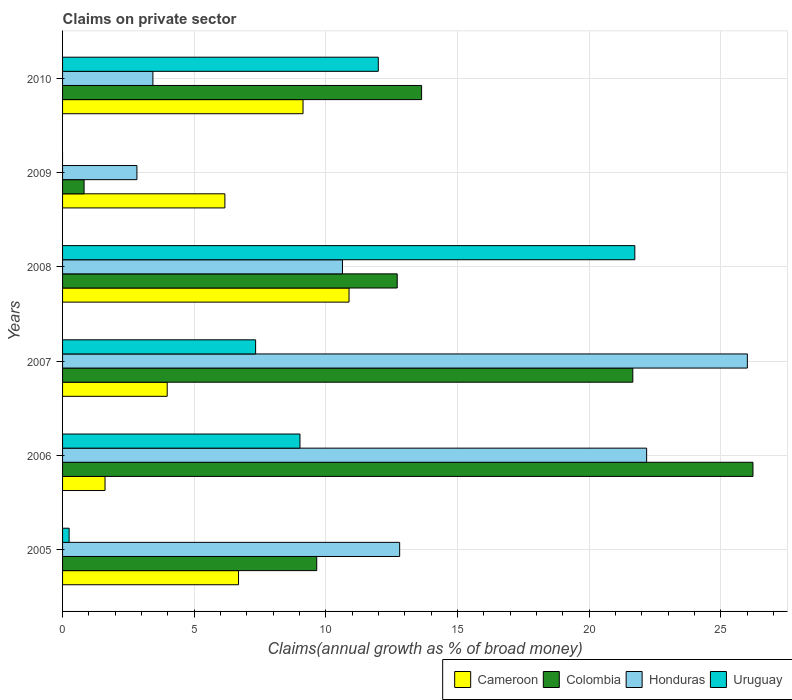How many different coloured bars are there?
Give a very brief answer. 4. How many groups of bars are there?
Offer a very short reply. 6. How many bars are there on the 2nd tick from the top?
Your response must be concise. 3. How many bars are there on the 6th tick from the bottom?
Provide a succinct answer. 4. What is the percentage of broad money claimed on private sector in Colombia in 2007?
Make the answer very short. 21.66. Across all years, what is the maximum percentage of broad money claimed on private sector in Cameroon?
Your answer should be compact. 10.88. Across all years, what is the minimum percentage of broad money claimed on private sector in Cameroon?
Your answer should be compact. 1.61. In which year was the percentage of broad money claimed on private sector in Colombia maximum?
Offer a terse response. 2006. What is the total percentage of broad money claimed on private sector in Cameroon in the graph?
Your answer should be compact. 38.45. What is the difference between the percentage of broad money claimed on private sector in Honduras in 2008 and that in 2009?
Offer a terse response. 7.81. What is the difference between the percentage of broad money claimed on private sector in Uruguay in 2006 and the percentage of broad money claimed on private sector in Honduras in 2009?
Give a very brief answer. 6.19. What is the average percentage of broad money claimed on private sector in Colombia per year?
Offer a terse response. 14.12. In the year 2008, what is the difference between the percentage of broad money claimed on private sector in Uruguay and percentage of broad money claimed on private sector in Honduras?
Your answer should be compact. 11.11. What is the ratio of the percentage of broad money claimed on private sector in Cameroon in 2005 to that in 2010?
Offer a terse response. 0.73. Is the percentage of broad money claimed on private sector in Cameroon in 2006 less than that in 2007?
Keep it short and to the point. Yes. Is the difference between the percentage of broad money claimed on private sector in Uruguay in 2007 and 2010 greater than the difference between the percentage of broad money claimed on private sector in Honduras in 2007 and 2010?
Your answer should be very brief. No. What is the difference between the highest and the second highest percentage of broad money claimed on private sector in Cameroon?
Keep it short and to the point. 1.75. What is the difference between the highest and the lowest percentage of broad money claimed on private sector in Cameroon?
Offer a terse response. 9.27. In how many years, is the percentage of broad money claimed on private sector in Uruguay greater than the average percentage of broad money claimed on private sector in Uruguay taken over all years?
Offer a terse response. 3. Are all the bars in the graph horizontal?
Your response must be concise. Yes. Does the graph contain grids?
Provide a succinct answer. Yes. What is the title of the graph?
Offer a very short reply. Claims on private sector. Does "Belize" appear as one of the legend labels in the graph?
Give a very brief answer. No. What is the label or title of the X-axis?
Give a very brief answer. Claims(annual growth as % of broad money). What is the label or title of the Y-axis?
Your answer should be very brief. Years. What is the Claims(annual growth as % of broad money) of Cameroon in 2005?
Ensure brevity in your answer.  6.68. What is the Claims(annual growth as % of broad money) of Colombia in 2005?
Offer a very short reply. 9.66. What is the Claims(annual growth as % of broad money) in Honduras in 2005?
Provide a short and direct response. 12.8. What is the Claims(annual growth as % of broad money) in Uruguay in 2005?
Provide a succinct answer. 0.25. What is the Claims(annual growth as % of broad money) of Cameroon in 2006?
Ensure brevity in your answer.  1.61. What is the Claims(annual growth as % of broad money) in Colombia in 2006?
Your answer should be very brief. 26.22. What is the Claims(annual growth as % of broad money) in Honduras in 2006?
Provide a short and direct response. 22.19. What is the Claims(annual growth as % of broad money) of Uruguay in 2006?
Offer a terse response. 9.02. What is the Claims(annual growth as % of broad money) in Cameroon in 2007?
Ensure brevity in your answer.  3.97. What is the Claims(annual growth as % of broad money) in Colombia in 2007?
Your answer should be compact. 21.66. What is the Claims(annual growth as % of broad money) in Honduras in 2007?
Offer a terse response. 26.01. What is the Claims(annual growth as % of broad money) of Uruguay in 2007?
Give a very brief answer. 7.33. What is the Claims(annual growth as % of broad money) of Cameroon in 2008?
Offer a very short reply. 10.88. What is the Claims(annual growth as % of broad money) in Colombia in 2008?
Provide a short and direct response. 12.71. What is the Claims(annual growth as % of broad money) of Honduras in 2008?
Your answer should be very brief. 10.63. What is the Claims(annual growth as % of broad money) in Uruguay in 2008?
Make the answer very short. 21.74. What is the Claims(annual growth as % of broad money) of Cameroon in 2009?
Give a very brief answer. 6.17. What is the Claims(annual growth as % of broad money) in Colombia in 2009?
Provide a short and direct response. 0.82. What is the Claims(annual growth as % of broad money) in Honduras in 2009?
Your response must be concise. 2.82. What is the Claims(annual growth as % of broad money) in Cameroon in 2010?
Offer a very short reply. 9.13. What is the Claims(annual growth as % of broad money) of Colombia in 2010?
Ensure brevity in your answer.  13.64. What is the Claims(annual growth as % of broad money) in Honduras in 2010?
Offer a very short reply. 3.43. What is the Claims(annual growth as % of broad money) of Uruguay in 2010?
Make the answer very short. 11.99. Across all years, what is the maximum Claims(annual growth as % of broad money) in Cameroon?
Offer a terse response. 10.88. Across all years, what is the maximum Claims(annual growth as % of broad money) in Colombia?
Your response must be concise. 26.22. Across all years, what is the maximum Claims(annual growth as % of broad money) in Honduras?
Your answer should be very brief. 26.01. Across all years, what is the maximum Claims(annual growth as % of broad money) in Uruguay?
Your answer should be very brief. 21.74. Across all years, what is the minimum Claims(annual growth as % of broad money) in Cameroon?
Provide a short and direct response. 1.61. Across all years, what is the minimum Claims(annual growth as % of broad money) of Colombia?
Provide a short and direct response. 0.82. Across all years, what is the minimum Claims(annual growth as % of broad money) of Honduras?
Provide a succinct answer. 2.82. What is the total Claims(annual growth as % of broad money) of Cameroon in the graph?
Give a very brief answer. 38.45. What is the total Claims(annual growth as % of broad money) in Colombia in the graph?
Keep it short and to the point. 84.71. What is the total Claims(annual growth as % of broad money) in Honduras in the graph?
Give a very brief answer. 77.89. What is the total Claims(annual growth as % of broad money) in Uruguay in the graph?
Offer a terse response. 50.33. What is the difference between the Claims(annual growth as % of broad money) of Cameroon in 2005 and that in 2006?
Your response must be concise. 5.07. What is the difference between the Claims(annual growth as % of broad money) in Colombia in 2005 and that in 2006?
Provide a succinct answer. -16.57. What is the difference between the Claims(annual growth as % of broad money) in Honduras in 2005 and that in 2006?
Provide a succinct answer. -9.38. What is the difference between the Claims(annual growth as % of broad money) of Uruguay in 2005 and that in 2006?
Your answer should be very brief. -8.77. What is the difference between the Claims(annual growth as % of broad money) in Cameroon in 2005 and that in 2007?
Offer a very short reply. 2.71. What is the difference between the Claims(annual growth as % of broad money) in Colombia in 2005 and that in 2007?
Ensure brevity in your answer.  -12.01. What is the difference between the Claims(annual growth as % of broad money) in Honduras in 2005 and that in 2007?
Make the answer very short. -13.21. What is the difference between the Claims(annual growth as % of broad money) of Uruguay in 2005 and that in 2007?
Your answer should be compact. -7.08. What is the difference between the Claims(annual growth as % of broad money) of Cameroon in 2005 and that in 2008?
Ensure brevity in your answer.  -4.2. What is the difference between the Claims(annual growth as % of broad money) of Colombia in 2005 and that in 2008?
Make the answer very short. -3.06. What is the difference between the Claims(annual growth as % of broad money) of Honduras in 2005 and that in 2008?
Provide a short and direct response. 2.17. What is the difference between the Claims(annual growth as % of broad money) in Uruguay in 2005 and that in 2008?
Offer a terse response. -21.49. What is the difference between the Claims(annual growth as % of broad money) in Cameroon in 2005 and that in 2009?
Your answer should be very brief. 0.52. What is the difference between the Claims(annual growth as % of broad money) of Colombia in 2005 and that in 2009?
Provide a succinct answer. 8.84. What is the difference between the Claims(annual growth as % of broad money) in Honduras in 2005 and that in 2009?
Your answer should be very brief. 9.98. What is the difference between the Claims(annual growth as % of broad money) of Cameroon in 2005 and that in 2010?
Offer a very short reply. -2.45. What is the difference between the Claims(annual growth as % of broad money) in Colombia in 2005 and that in 2010?
Ensure brevity in your answer.  -3.98. What is the difference between the Claims(annual growth as % of broad money) in Honduras in 2005 and that in 2010?
Your answer should be very brief. 9.37. What is the difference between the Claims(annual growth as % of broad money) in Uruguay in 2005 and that in 2010?
Your answer should be very brief. -11.74. What is the difference between the Claims(annual growth as % of broad money) of Cameroon in 2006 and that in 2007?
Make the answer very short. -2.36. What is the difference between the Claims(annual growth as % of broad money) of Colombia in 2006 and that in 2007?
Ensure brevity in your answer.  4.56. What is the difference between the Claims(annual growth as % of broad money) of Honduras in 2006 and that in 2007?
Your answer should be very brief. -3.83. What is the difference between the Claims(annual growth as % of broad money) in Uruguay in 2006 and that in 2007?
Make the answer very short. 1.68. What is the difference between the Claims(annual growth as % of broad money) of Cameroon in 2006 and that in 2008?
Keep it short and to the point. -9.27. What is the difference between the Claims(annual growth as % of broad money) in Colombia in 2006 and that in 2008?
Your answer should be compact. 13.51. What is the difference between the Claims(annual growth as % of broad money) of Honduras in 2006 and that in 2008?
Your answer should be compact. 11.55. What is the difference between the Claims(annual growth as % of broad money) of Uruguay in 2006 and that in 2008?
Your answer should be very brief. -12.72. What is the difference between the Claims(annual growth as % of broad money) of Cameroon in 2006 and that in 2009?
Your response must be concise. -4.55. What is the difference between the Claims(annual growth as % of broad money) of Colombia in 2006 and that in 2009?
Make the answer very short. 25.41. What is the difference between the Claims(annual growth as % of broad money) of Honduras in 2006 and that in 2009?
Offer a terse response. 19.36. What is the difference between the Claims(annual growth as % of broad money) of Cameroon in 2006 and that in 2010?
Your answer should be very brief. -7.52. What is the difference between the Claims(annual growth as % of broad money) of Colombia in 2006 and that in 2010?
Ensure brevity in your answer.  12.59. What is the difference between the Claims(annual growth as % of broad money) of Honduras in 2006 and that in 2010?
Keep it short and to the point. 18.75. What is the difference between the Claims(annual growth as % of broad money) in Uruguay in 2006 and that in 2010?
Your answer should be very brief. -2.97. What is the difference between the Claims(annual growth as % of broad money) of Cameroon in 2007 and that in 2008?
Your response must be concise. -6.91. What is the difference between the Claims(annual growth as % of broad money) in Colombia in 2007 and that in 2008?
Provide a succinct answer. 8.95. What is the difference between the Claims(annual growth as % of broad money) of Honduras in 2007 and that in 2008?
Your answer should be compact. 15.38. What is the difference between the Claims(annual growth as % of broad money) of Uruguay in 2007 and that in 2008?
Provide a short and direct response. -14.4. What is the difference between the Claims(annual growth as % of broad money) in Cameroon in 2007 and that in 2009?
Ensure brevity in your answer.  -2.19. What is the difference between the Claims(annual growth as % of broad money) of Colombia in 2007 and that in 2009?
Offer a very short reply. 20.84. What is the difference between the Claims(annual growth as % of broad money) in Honduras in 2007 and that in 2009?
Offer a very short reply. 23.19. What is the difference between the Claims(annual growth as % of broad money) in Cameroon in 2007 and that in 2010?
Offer a very short reply. -5.16. What is the difference between the Claims(annual growth as % of broad money) in Colombia in 2007 and that in 2010?
Provide a short and direct response. 8.02. What is the difference between the Claims(annual growth as % of broad money) in Honduras in 2007 and that in 2010?
Your answer should be compact. 22.58. What is the difference between the Claims(annual growth as % of broad money) of Uruguay in 2007 and that in 2010?
Keep it short and to the point. -4.66. What is the difference between the Claims(annual growth as % of broad money) in Cameroon in 2008 and that in 2009?
Provide a succinct answer. 4.72. What is the difference between the Claims(annual growth as % of broad money) of Colombia in 2008 and that in 2009?
Provide a succinct answer. 11.89. What is the difference between the Claims(annual growth as % of broad money) in Honduras in 2008 and that in 2009?
Offer a very short reply. 7.81. What is the difference between the Claims(annual growth as % of broad money) in Cameroon in 2008 and that in 2010?
Provide a short and direct response. 1.75. What is the difference between the Claims(annual growth as % of broad money) of Colombia in 2008 and that in 2010?
Your response must be concise. -0.93. What is the difference between the Claims(annual growth as % of broad money) in Honduras in 2008 and that in 2010?
Make the answer very short. 7.2. What is the difference between the Claims(annual growth as % of broad money) in Uruguay in 2008 and that in 2010?
Ensure brevity in your answer.  9.74. What is the difference between the Claims(annual growth as % of broad money) of Cameroon in 2009 and that in 2010?
Make the answer very short. -2.97. What is the difference between the Claims(annual growth as % of broad money) of Colombia in 2009 and that in 2010?
Provide a short and direct response. -12.82. What is the difference between the Claims(annual growth as % of broad money) in Honduras in 2009 and that in 2010?
Your answer should be compact. -0.61. What is the difference between the Claims(annual growth as % of broad money) in Cameroon in 2005 and the Claims(annual growth as % of broad money) in Colombia in 2006?
Give a very brief answer. -19.54. What is the difference between the Claims(annual growth as % of broad money) of Cameroon in 2005 and the Claims(annual growth as % of broad money) of Honduras in 2006?
Keep it short and to the point. -15.5. What is the difference between the Claims(annual growth as % of broad money) in Cameroon in 2005 and the Claims(annual growth as % of broad money) in Uruguay in 2006?
Provide a short and direct response. -2.33. What is the difference between the Claims(annual growth as % of broad money) of Colombia in 2005 and the Claims(annual growth as % of broad money) of Honduras in 2006?
Offer a terse response. -12.53. What is the difference between the Claims(annual growth as % of broad money) in Colombia in 2005 and the Claims(annual growth as % of broad money) in Uruguay in 2006?
Offer a terse response. 0.64. What is the difference between the Claims(annual growth as % of broad money) of Honduras in 2005 and the Claims(annual growth as % of broad money) of Uruguay in 2006?
Give a very brief answer. 3.79. What is the difference between the Claims(annual growth as % of broad money) of Cameroon in 2005 and the Claims(annual growth as % of broad money) of Colombia in 2007?
Give a very brief answer. -14.98. What is the difference between the Claims(annual growth as % of broad money) in Cameroon in 2005 and the Claims(annual growth as % of broad money) in Honduras in 2007?
Provide a succinct answer. -19.33. What is the difference between the Claims(annual growth as % of broad money) in Cameroon in 2005 and the Claims(annual growth as % of broad money) in Uruguay in 2007?
Provide a short and direct response. -0.65. What is the difference between the Claims(annual growth as % of broad money) of Colombia in 2005 and the Claims(annual growth as % of broad money) of Honduras in 2007?
Offer a terse response. -16.36. What is the difference between the Claims(annual growth as % of broad money) in Colombia in 2005 and the Claims(annual growth as % of broad money) in Uruguay in 2007?
Offer a very short reply. 2.32. What is the difference between the Claims(annual growth as % of broad money) in Honduras in 2005 and the Claims(annual growth as % of broad money) in Uruguay in 2007?
Provide a short and direct response. 5.47. What is the difference between the Claims(annual growth as % of broad money) in Cameroon in 2005 and the Claims(annual growth as % of broad money) in Colombia in 2008?
Keep it short and to the point. -6.03. What is the difference between the Claims(annual growth as % of broad money) in Cameroon in 2005 and the Claims(annual growth as % of broad money) in Honduras in 2008?
Ensure brevity in your answer.  -3.95. What is the difference between the Claims(annual growth as % of broad money) of Cameroon in 2005 and the Claims(annual growth as % of broad money) of Uruguay in 2008?
Give a very brief answer. -15.05. What is the difference between the Claims(annual growth as % of broad money) of Colombia in 2005 and the Claims(annual growth as % of broad money) of Honduras in 2008?
Your answer should be very brief. -0.98. What is the difference between the Claims(annual growth as % of broad money) of Colombia in 2005 and the Claims(annual growth as % of broad money) of Uruguay in 2008?
Keep it short and to the point. -12.08. What is the difference between the Claims(annual growth as % of broad money) of Honduras in 2005 and the Claims(annual growth as % of broad money) of Uruguay in 2008?
Provide a short and direct response. -8.93. What is the difference between the Claims(annual growth as % of broad money) of Cameroon in 2005 and the Claims(annual growth as % of broad money) of Colombia in 2009?
Give a very brief answer. 5.87. What is the difference between the Claims(annual growth as % of broad money) in Cameroon in 2005 and the Claims(annual growth as % of broad money) in Honduras in 2009?
Your response must be concise. 3.86. What is the difference between the Claims(annual growth as % of broad money) in Colombia in 2005 and the Claims(annual growth as % of broad money) in Honduras in 2009?
Your response must be concise. 6.83. What is the difference between the Claims(annual growth as % of broad money) of Cameroon in 2005 and the Claims(annual growth as % of broad money) of Colombia in 2010?
Offer a terse response. -6.95. What is the difference between the Claims(annual growth as % of broad money) in Cameroon in 2005 and the Claims(annual growth as % of broad money) in Honduras in 2010?
Keep it short and to the point. 3.25. What is the difference between the Claims(annual growth as % of broad money) in Cameroon in 2005 and the Claims(annual growth as % of broad money) in Uruguay in 2010?
Provide a succinct answer. -5.31. What is the difference between the Claims(annual growth as % of broad money) of Colombia in 2005 and the Claims(annual growth as % of broad money) of Honduras in 2010?
Your response must be concise. 6.22. What is the difference between the Claims(annual growth as % of broad money) in Colombia in 2005 and the Claims(annual growth as % of broad money) in Uruguay in 2010?
Your answer should be very brief. -2.34. What is the difference between the Claims(annual growth as % of broad money) in Honduras in 2005 and the Claims(annual growth as % of broad money) in Uruguay in 2010?
Provide a succinct answer. 0.81. What is the difference between the Claims(annual growth as % of broad money) of Cameroon in 2006 and the Claims(annual growth as % of broad money) of Colombia in 2007?
Give a very brief answer. -20.05. What is the difference between the Claims(annual growth as % of broad money) of Cameroon in 2006 and the Claims(annual growth as % of broad money) of Honduras in 2007?
Your answer should be very brief. -24.4. What is the difference between the Claims(annual growth as % of broad money) in Cameroon in 2006 and the Claims(annual growth as % of broad money) in Uruguay in 2007?
Provide a succinct answer. -5.72. What is the difference between the Claims(annual growth as % of broad money) in Colombia in 2006 and the Claims(annual growth as % of broad money) in Honduras in 2007?
Your answer should be very brief. 0.21. What is the difference between the Claims(annual growth as % of broad money) in Colombia in 2006 and the Claims(annual growth as % of broad money) in Uruguay in 2007?
Your response must be concise. 18.89. What is the difference between the Claims(annual growth as % of broad money) in Honduras in 2006 and the Claims(annual growth as % of broad money) in Uruguay in 2007?
Your answer should be compact. 14.85. What is the difference between the Claims(annual growth as % of broad money) in Cameroon in 2006 and the Claims(annual growth as % of broad money) in Colombia in 2008?
Your answer should be compact. -11.1. What is the difference between the Claims(annual growth as % of broad money) in Cameroon in 2006 and the Claims(annual growth as % of broad money) in Honduras in 2008?
Keep it short and to the point. -9.02. What is the difference between the Claims(annual growth as % of broad money) in Cameroon in 2006 and the Claims(annual growth as % of broad money) in Uruguay in 2008?
Give a very brief answer. -20.12. What is the difference between the Claims(annual growth as % of broad money) in Colombia in 2006 and the Claims(annual growth as % of broad money) in Honduras in 2008?
Ensure brevity in your answer.  15.59. What is the difference between the Claims(annual growth as % of broad money) in Colombia in 2006 and the Claims(annual growth as % of broad money) in Uruguay in 2008?
Ensure brevity in your answer.  4.49. What is the difference between the Claims(annual growth as % of broad money) in Honduras in 2006 and the Claims(annual growth as % of broad money) in Uruguay in 2008?
Your answer should be compact. 0.45. What is the difference between the Claims(annual growth as % of broad money) of Cameroon in 2006 and the Claims(annual growth as % of broad money) of Colombia in 2009?
Your response must be concise. 0.8. What is the difference between the Claims(annual growth as % of broad money) of Cameroon in 2006 and the Claims(annual growth as % of broad money) of Honduras in 2009?
Your answer should be very brief. -1.21. What is the difference between the Claims(annual growth as % of broad money) in Colombia in 2006 and the Claims(annual growth as % of broad money) in Honduras in 2009?
Keep it short and to the point. 23.4. What is the difference between the Claims(annual growth as % of broad money) of Cameroon in 2006 and the Claims(annual growth as % of broad money) of Colombia in 2010?
Ensure brevity in your answer.  -12.02. What is the difference between the Claims(annual growth as % of broad money) in Cameroon in 2006 and the Claims(annual growth as % of broad money) in Honduras in 2010?
Your answer should be very brief. -1.82. What is the difference between the Claims(annual growth as % of broad money) in Cameroon in 2006 and the Claims(annual growth as % of broad money) in Uruguay in 2010?
Give a very brief answer. -10.38. What is the difference between the Claims(annual growth as % of broad money) in Colombia in 2006 and the Claims(annual growth as % of broad money) in Honduras in 2010?
Provide a short and direct response. 22.79. What is the difference between the Claims(annual growth as % of broad money) of Colombia in 2006 and the Claims(annual growth as % of broad money) of Uruguay in 2010?
Your answer should be very brief. 14.23. What is the difference between the Claims(annual growth as % of broad money) in Honduras in 2006 and the Claims(annual growth as % of broad money) in Uruguay in 2010?
Make the answer very short. 10.19. What is the difference between the Claims(annual growth as % of broad money) in Cameroon in 2007 and the Claims(annual growth as % of broad money) in Colombia in 2008?
Your response must be concise. -8.74. What is the difference between the Claims(annual growth as % of broad money) in Cameroon in 2007 and the Claims(annual growth as % of broad money) in Honduras in 2008?
Your answer should be compact. -6.66. What is the difference between the Claims(annual growth as % of broad money) in Cameroon in 2007 and the Claims(annual growth as % of broad money) in Uruguay in 2008?
Ensure brevity in your answer.  -17.76. What is the difference between the Claims(annual growth as % of broad money) of Colombia in 2007 and the Claims(annual growth as % of broad money) of Honduras in 2008?
Make the answer very short. 11.03. What is the difference between the Claims(annual growth as % of broad money) of Colombia in 2007 and the Claims(annual growth as % of broad money) of Uruguay in 2008?
Ensure brevity in your answer.  -0.08. What is the difference between the Claims(annual growth as % of broad money) in Honduras in 2007 and the Claims(annual growth as % of broad money) in Uruguay in 2008?
Ensure brevity in your answer.  4.27. What is the difference between the Claims(annual growth as % of broad money) of Cameroon in 2007 and the Claims(annual growth as % of broad money) of Colombia in 2009?
Provide a short and direct response. 3.16. What is the difference between the Claims(annual growth as % of broad money) of Cameroon in 2007 and the Claims(annual growth as % of broad money) of Honduras in 2009?
Offer a very short reply. 1.15. What is the difference between the Claims(annual growth as % of broad money) in Colombia in 2007 and the Claims(annual growth as % of broad money) in Honduras in 2009?
Keep it short and to the point. 18.84. What is the difference between the Claims(annual growth as % of broad money) of Cameroon in 2007 and the Claims(annual growth as % of broad money) of Colombia in 2010?
Keep it short and to the point. -9.66. What is the difference between the Claims(annual growth as % of broad money) in Cameroon in 2007 and the Claims(annual growth as % of broad money) in Honduras in 2010?
Offer a terse response. 0.54. What is the difference between the Claims(annual growth as % of broad money) of Cameroon in 2007 and the Claims(annual growth as % of broad money) of Uruguay in 2010?
Ensure brevity in your answer.  -8.02. What is the difference between the Claims(annual growth as % of broad money) of Colombia in 2007 and the Claims(annual growth as % of broad money) of Honduras in 2010?
Your response must be concise. 18.23. What is the difference between the Claims(annual growth as % of broad money) in Colombia in 2007 and the Claims(annual growth as % of broad money) in Uruguay in 2010?
Your answer should be very brief. 9.67. What is the difference between the Claims(annual growth as % of broad money) of Honduras in 2007 and the Claims(annual growth as % of broad money) of Uruguay in 2010?
Keep it short and to the point. 14.02. What is the difference between the Claims(annual growth as % of broad money) of Cameroon in 2008 and the Claims(annual growth as % of broad money) of Colombia in 2009?
Ensure brevity in your answer.  10.06. What is the difference between the Claims(annual growth as % of broad money) in Cameroon in 2008 and the Claims(annual growth as % of broad money) in Honduras in 2009?
Give a very brief answer. 8.06. What is the difference between the Claims(annual growth as % of broad money) of Colombia in 2008 and the Claims(annual growth as % of broad money) of Honduras in 2009?
Keep it short and to the point. 9.89. What is the difference between the Claims(annual growth as % of broad money) of Cameroon in 2008 and the Claims(annual growth as % of broad money) of Colombia in 2010?
Provide a short and direct response. -2.76. What is the difference between the Claims(annual growth as % of broad money) in Cameroon in 2008 and the Claims(annual growth as % of broad money) in Honduras in 2010?
Make the answer very short. 7.45. What is the difference between the Claims(annual growth as % of broad money) of Cameroon in 2008 and the Claims(annual growth as % of broad money) of Uruguay in 2010?
Provide a short and direct response. -1.11. What is the difference between the Claims(annual growth as % of broad money) in Colombia in 2008 and the Claims(annual growth as % of broad money) in Honduras in 2010?
Give a very brief answer. 9.28. What is the difference between the Claims(annual growth as % of broad money) in Colombia in 2008 and the Claims(annual growth as % of broad money) in Uruguay in 2010?
Your answer should be very brief. 0.72. What is the difference between the Claims(annual growth as % of broad money) in Honduras in 2008 and the Claims(annual growth as % of broad money) in Uruguay in 2010?
Keep it short and to the point. -1.36. What is the difference between the Claims(annual growth as % of broad money) of Cameroon in 2009 and the Claims(annual growth as % of broad money) of Colombia in 2010?
Keep it short and to the point. -7.47. What is the difference between the Claims(annual growth as % of broad money) of Cameroon in 2009 and the Claims(annual growth as % of broad money) of Honduras in 2010?
Ensure brevity in your answer.  2.73. What is the difference between the Claims(annual growth as % of broad money) of Cameroon in 2009 and the Claims(annual growth as % of broad money) of Uruguay in 2010?
Keep it short and to the point. -5.83. What is the difference between the Claims(annual growth as % of broad money) of Colombia in 2009 and the Claims(annual growth as % of broad money) of Honduras in 2010?
Provide a short and direct response. -2.61. What is the difference between the Claims(annual growth as % of broad money) of Colombia in 2009 and the Claims(annual growth as % of broad money) of Uruguay in 2010?
Your answer should be very brief. -11.18. What is the difference between the Claims(annual growth as % of broad money) in Honduras in 2009 and the Claims(annual growth as % of broad money) in Uruguay in 2010?
Provide a succinct answer. -9.17. What is the average Claims(annual growth as % of broad money) in Cameroon per year?
Provide a succinct answer. 6.41. What is the average Claims(annual growth as % of broad money) of Colombia per year?
Ensure brevity in your answer.  14.12. What is the average Claims(annual growth as % of broad money) in Honduras per year?
Ensure brevity in your answer.  12.98. What is the average Claims(annual growth as % of broad money) in Uruguay per year?
Offer a terse response. 8.39. In the year 2005, what is the difference between the Claims(annual growth as % of broad money) in Cameroon and Claims(annual growth as % of broad money) in Colombia?
Your answer should be very brief. -2.97. In the year 2005, what is the difference between the Claims(annual growth as % of broad money) of Cameroon and Claims(annual growth as % of broad money) of Honduras?
Provide a short and direct response. -6.12. In the year 2005, what is the difference between the Claims(annual growth as % of broad money) of Cameroon and Claims(annual growth as % of broad money) of Uruguay?
Make the answer very short. 6.44. In the year 2005, what is the difference between the Claims(annual growth as % of broad money) of Colombia and Claims(annual growth as % of broad money) of Honduras?
Make the answer very short. -3.15. In the year 2005, what is the difference between the Claims(annual growth as % of broad money) in Colombia and Claims(annual growth as % of broad money) in Uruguay?
Ensure brevity in your answer.  9.41. In the year 2005, what is the difference between the Claims(annual growth as % of broad money) in Honduras and Claims(annual growth as % of broad money) in Uruguay?
Provide a succinct answer. 12.56. In the year 2006, what is the difference between the Claims(annual growth as % of broad money) of Cameroon and Claims(annual growth as % of broad money) of Colombia?
Provide a short and direct response. -24.61. In the year 2006, what is the difference between the Claims(annual growth as % of broad money) in Cameroon and Claims(annual growth as % of broad money) in Honduras?
Your response must be concise. -20.57. In the year 2006, what is the difference between the Claims(annual growth as % of broad money) in Cameroon and Claims(annual growth as % of broad money) in Uruguay?
Your response must be concise. -7.4. In the year 2006, what is the difference between the Claims(annual growth as % of broad money) of Colombia and Claims(annual growth as % of broad money) of Honduras?
Offer a very short reply. 4.04. In the year 2006, what is the difference between the Claims(annual growth as % of broad money) in Colombia and Claims(annual growth as % of broad money) in Uruguay?
Provide a short and direct response. 17.21. In the year 2006, what is the difference between the Claims(annual growth as % of broad money) of Honduras and Claims(annual growth as % of broad money) of Uruguay?
Provide a succinct answer. 13.17. In the year 2007, what is the difference between the Claims(annual growth as % of broad money) of Cameroon and Claims(annual growth as % of broad money) of Colombia?
Offer a terse response. -17.69. In the year 2007, what is the difference between the Claims(annual growth as % of broad money) of Cameroon and Claims(annual growth as % of broad money) of Honduras?
Offer a terse response. -22.04. In the year 2007, what is the difference between the Claims(annual growth as % of broad money) of Cameroon and Claims(annual growth as % of broad money) of Uruguay?
Make the answer very short. -3.36. In the year 2007, what is the difference between the Claims(annual growth as % of broad money) of Colombia and Claims(annual growth as % of broad money) of Honduras?
Your response must be concise. -4.35. In the year 2007, what is the difference between the Claims(annual growth as % of broad money) in Colombia and Claims(annual growth as % of broad money) in Uruguay?
Provide a short and direct response. 14.33. In the year 2007, what is the difference between the Claims(annual growth as % of broad money) of Honduras and Claims(annual growth as % of broad money) of Uruguay?
Give a very brief answer. 18.68. In the year 2008, what is the difference between the Claims(annual growth as % of broad money) of Cameroon and Claims(annual growth as % of broad money) of Colombia?
Keep it short and to the point. -1.83. In the year 2008, what is the difference between the Claims(annual growth as % of broad money) of Cameroon and Claims(annual growth as % of broad money) of Honduras?
Offer a very short reply. 0.25. In the year 2008, what is the difference between the Claims(annual growth as % of broad money) of Cameroon and Claims(annual growth as % of broad money) of Uruguay?
Offer a terse response. -10.86. In the year 2008, what is the difference between the Claims(annual growth as % of broad money) of Colombia and Claims(annual growth as % of broad money) of Honduras?
Offer a terse response. 2.08. In the year 2008, what is the difference between the Claims(annual growth as % of broad money) of Colombia and Claims(annual growth as % of broad money) of Uruguay?
Make the answer very short. -9.03. In the year 2008, what is the difference between the Claims(annual growth as % of broad money) in Honduras and Claims(annual growth as % of broad money) in Uruguay?
Provide a succinct answer. -11.11. In the year 2009, what is the difference between the Claims(annual growth as % of broad money) in Cameroon and Claims(annual growth as % of broad money) in Colombia?
Offer a very short reply. 5.35. In the year 2009, what is the difference between the Claims(annual growth as % of broad money) in Cameroon and Claims(annual growth as % of broad money) in Honduras?
Offer a very short reply. 3.34. In the year 2009, what is the difference between the Claims(annual growth as % of broad money) of Colombia and Claims(annual growth as % of broad money) of Honduras?
Your answer should be very brief. -2.01. In the year 2010, what is the difference between the Claims(annual growth as % of broad money) of Cameroon and Claims(annual growth as % of broad money) of Colombia?
Provide a short and direct response. -4.5. In the year 2010, what is the difference between the Claims(annual growth as % of broad money) in Cameroon and Claims(annual growth as % of broad money) in Honduras?
Keep it short and to the point. 5.7. In the year 2010, what is the difference between the Claims(annual growth as % of broad money) in Cameroon and Claims(annual growth as % of broad money) in Uruguay?
Offer a terse response. -2.86. In the year 2010, what is the difference between the Claims(annual growth as % of broad money) in Colombia and Claims(annual growth as % of broad money) in Honduras?
Your answer should be very brief. 10.21. In the year 2010, what is the difference between the Claims(annual growth as % of broad money) in Colombia and Claims(annual growth as % of broad money) in Uruguay?
Provide a succinct answer. 1.64. In the year 2010, what is the difference between the Claims(annual growth as % of broad money) of Honduras and Claims(annual growth as % of broad money) of Uruguay?
Offer a terse response. -8.56. What is the ratio of the Claims(annual growth as % of broad money) in Cameroon in 2005 to that in 2006?
Offer a very short reply. 4.14. What is the ratio of the Claims(annual growth as % of broad money) of Colombia in 2005 to that in 2006?
Your answer should be very brief. 0.37. What is the ratio of the Claims(annual growth as % of broad money) of Honduras in 2005 to that in 2006?
Provide a succinct answer. 0.58. What is the ratio of the Claims(annual growth as % of broad money) of Uruguay in 2005 to that in 2006?
Offer a very short reply. 0.03. What is the ratio of the Claims(annual growth as % of broad money) of Cameroon in 2005 to that in 2007?
Ensure brevity in your answer.  1.68. What is the ratio of the Claims(annual growth as % of broad money) of Colombia in 2005 to that in 2007?
Your answer should be compact. 0.45. What is the ratio of the Claims(annual growth as % of broad money) in Honduras in 2005 to that in 2007?
Your response must be concise. 0.49. What is the ratio of the Claims(annual growth as % of broad money) in Uruguay in 2005 to that in 2007?
Make the answer very short. 0.03. What is the ratio of the Claims(annual growth as % of broad money) in Cameroon in 2005 to that in 2008?
Provide a succinct answer. 0.61. What is the ratio of the Claims(annual growth as % of broad money) in Colombia in 2005 to that in 2008?
Keep it short and to the point. 0.76. What is the ratio of the Claims(annual growth as % of broad money) of Honduras in 2005 to that in 2008?
Provide a succinct answer. 1.2. What is the ratio of the Claims(annual growth as % of broad money) in Uruguay in 2005 to that in 2008?
Your answer should be very brief. 0.01. What is the ratio of the Claims(annual growth as % of broad money) of Cameroon in 2005 to that in 2009?
Make the answer very short. 1.08. What is the ratio of the Claims(annual growth as % of broad money) in Colombia in 2005 to that in 2009?
Offer a terse response. 11.82. What is the ratio of the Claims(annual growth as % of broad money) in Honduras in 2005 to that in 2009?
Provide a short and direct response. 4.53. What is the ratio of the Claims(annual growth as % of broad money) of Cameroon in 2005 to that in 2010?
Your response must be concise. 0.73. What is the ratio of the Claims(annual growth as % of broad money) in Colombia in 2005 to that in 2010?
Your answer should be compact. 0.71. What is the ratio of the Claims(annual growth as % of broad money) in Honduras in 2005 to that in 2010?
Provide a short and direct response. 3.73. What is the ratio of the Claims(annual growth as % of broad money) in Uruguay in 2005 to that in 2010?
Offer a very short reply. 0.02. What is the ratio of the Claims(annual growth as % of broad money) in Cameroon in 2006 to that in 2007?
Offer a terse response. 0.41. What is the ratio of the Claims(annual growth as % of broad money) of Colombia in 2006 to that in 2007?
Make the answer very short. 1.21. What is the ratio of the Claims(annual growth as % of broad money) of Honduras in 2006 to that in 2007?
Offer a terse response. 0.85. What is the ratio of the Claims(annual growth as % of broad money) of Uruguay in 2006 to that in 2007?
Offer a very short reply. 1.23. What is the ratio of the Claims(annual growth as % of broad money) in Cameroon in 2006 to that in 2008?
Provide a succinct answer. 0.15. What is the ratio of the Claims(annual growth as % of broad money) of Colombia in 2006 to that in 2008?
Your answer should be very brief. 2.06. What is the ratio of the Claims(annual growth as % of broad money) of Honduras in 2006 to that in 2008?
Offer a terse response. 2.09. What is the ratio of the Claims(annual growth as % of broad money) in Uruguay in 2006 to that in 2008?
Make the answer very short. 0.41. What is the ratio of the Claims(annual growth as % of broad money) of Cameroon in 2006 to that in 2009?
Offer a very short reply. 0.26. What is the ratio of the Claims(annual growth as % of broad money) of Colombia in 2006 to that in 2009?
Your answer should be very brief. 32.1. What is the ratio of the Claims(annual growth as % of broad money) in Honduras in 2006 to that in 2009?
Provide a short and direct response. 7.86. What is the ratio of the Claims(annual growth as % of broad money) of Cameroon in 2006 to that in 2010?
Offer a terse response. 0.18. What is the ratio of the Claims(annual growth as % of broad money) in Colombia in 2006 to that in 2010?
Offer a terse response. 1.92. What is the ratio of the Claims(annual growth as % of broad money) in Honduras in 2006 to that in 2010?
Provide a short and direct response. 6.47. What is the ratio of the Claims(annual growth as % of broad money) in Uruguay in 2006 to that in 2010?
Provide a succinct answer. 0.75. What is the ratio of the Claims(annual growth as % of broad money) in Cameroon in 2007 to that in 2008?
Ensure brevity in your answer.  0.37. What is the ratio of the Claims(annual growth as % of broad money) of Colombia in 2007 to that in 2008?
Make the answer very short. 1.7. What is the ratio of the Claims(annual growth as % of broad money) in Honduras in 2007 to that in 2008?
Provide a short and direct response. 2.45. What is the ratio of the Claims(annual growth as % of broad money) of Uruguay in 2007 to that in 2008?
Offer a terse response. 0.34. What is the ratio of the Claims(annual growth as % of broad money) in Cameroon in 2007 to that in 2009?
Offer a terse response. 0.64. What is the ratio of the Claims(annual growth as % of broad money) of Colombia in 2007 to that in 2009?
Your response must be concise. 26.51. What is the ratio of the Claims(annual growth as % of broad money) in Honduras in 2007 to that in 2009?
Make the answer very short. 9.21. What is the ratio of the Claims(annual growth as % of broad money) in Cameroon in 2007 to that in 2010?
Ensure brevity in your answer.  0.44. What is the ratio of the Claims(annual growth as % of broad money) in Colombia in 2007 to that in 2010?
Make the answer very short. 1.59. What is the ratio of the Claims(annual growth as % of broad money) in Honduras in 2007 to that in 2010?
Your answer should be very brief. 7.58. What is the ratio of the Claims(annual growth as % of broad money) in Uruguay in 2007 to that in 2010?
Offer a very short reply. 0.61. What is the ratio of the Claims(annual growth as % of broad money) of Cameroon in 2008 to that in 2009?
Your answer should be compact. 1.76. What is the ratio of the Claims(annual growth as % of broad money) in Colombia in 2008 to that in 2009?
Your response must be concise. 15.56. What is the ratio of the Claims(annual growth as % of broad money) of Honduras in 2008 to that in 2009?
Provide a short and direct response. 3.76. What is the ratio of the Claims(annual growth as % of broad money) of Cameroon in 2008 to that in 2010?
Your response must be concise. 1.19. What is the ratio of the Claims(annual growth as % of broad money) in Colombia in 2008 to that in 2010?
Offer a very short reply. 0.93. What is the ratio of the Claims(annual growth as % of broad money) of Honduras in 2008 to that in 2010?
Offer a very short reply. 3.1. What is the ratio of the Claims(annual growth as % of broad money) of Uruguay in 2008 to that in 2010?
Your answer should be compact. 1.81. What is the ratio of the Claims(annual growth as % of broad money) of Cameroon in 2009 to that in 2010?
Offer a very short reply. 0.68. What is the ratio of the Claims(annual growth as % of broad money) in Colombia in 2009 to that in 2010?
Keep it short and to the point. 0.06. What is the ratio of the Claims(annual growth as % of broad money) of Honduras in 2009 to that in 2010?
Provide a short and direct response. 0.82. What is the difference between the highest and the second highest Claims(annual growth as % of broad money) in Cameroon?
Your response must be concise. 1.75. What is the difference between the highest and the second highest Claims(annual growth as % of broad money) of Colombia?
Ensure brevity in your answer.  4.56. What is the difference between the highest and the second highest Claims(annual growth as % of broad money) in Honduras?
Give a very brief answer. 3.83. What is the difference between the highest and the second highest Claims(annual growth as % of broad money) of Uruguay?
Keep it short and to the point. 9.74. What is the difference between the highest and the lowest Claims(annual growth as % of broad money) of Cameroon?
Your response must be concise. 9.27. What is the difference between the highest and the lowest Claims(annual growth as % of broad money) in Colombia?
Provide a succinct answer. 25.41. What is the difference between the highest and the lowest Claims(annual growth as % of broad money) in Honduras?
Your answer should be compact. 23.19. What is the difference between the highest and the lowest Claims(annual growth as % of broad money) in Uruguay?
Provide a short and direct response. 21.74. 